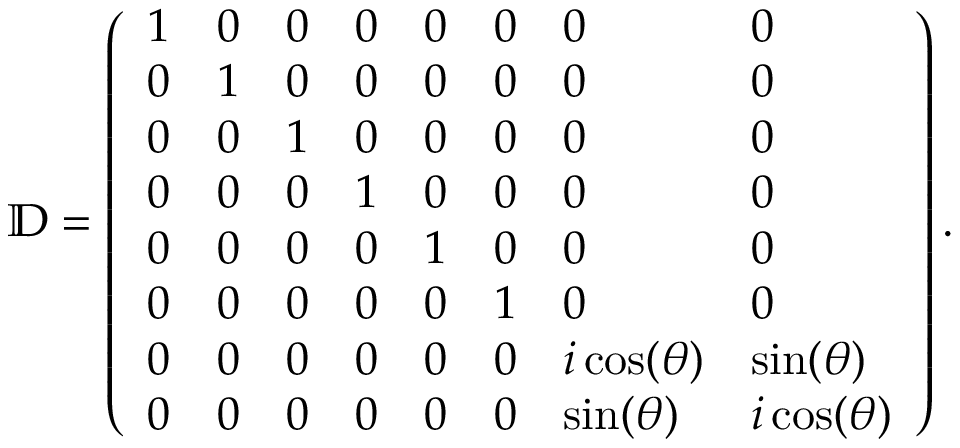<formula> <loc_0><loc_0><loc_500><loc_500>\mathbb { D } = \left ( \begin{array} { l l l l l l l l } { 1 } & { 0 } & { 0 } & { 0 } & { 0 } & { 0 } & { 0 } & { 0 } \\ { 0 } & { 1 } & { 0 } & { 0 } & { 0 } & { 0 } & { 0 } & { 0 } \\ { 0 } & { 0 } & { 1 } & { 0 } & { 0 } & { 0 } & { 0 } & { 0 } \\ { 0 } & { 0 } & { 0 } & { 1 } & { 0 } & { 0 } & { 0 } & { 0 } \\ { 0 } & { 0 } & { 0 } & { 0 } & { 1 } & { 0 } & { 0 } & { 0 } \\ { 0 } & { 0 } & { 0 } & { 0 } & { 0 } & { 1 } & { 0 } & { 0 } \\ { 0 } & { 0 } & { 0 } & { 0 } & { 0 } & { 0 } & { i \cos ( \theta ) } & { \sin ( \theta ) } \\ { 0 } & { 0 } & { 0 } & { 0 } & { 0 } & { 0 } & { \sin ( \theta ) } & { i \cos ( \theta ) } \end{array} \right ) .</formula> 